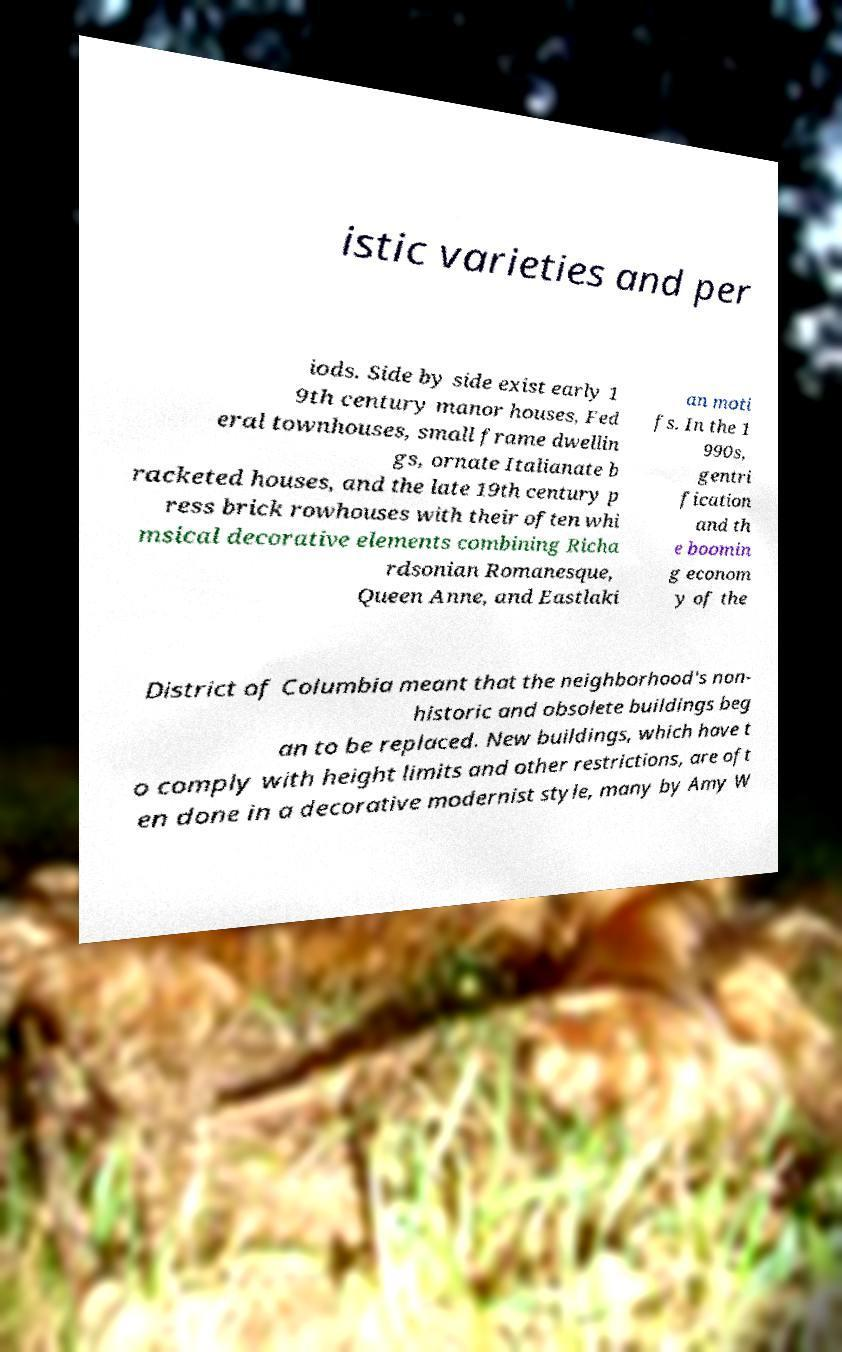Can you accurately transcribe the text from the provided image for me? istic varieties and per iods. Side by side exist early 1 9th century manor houses, Fed eral townhouses, small frame dwellin gs, ornate Italianate b racketed houses, and the late 19th century p ress brick rowhouses with their often whi msical decorative elements combining Richa rdsonian Romanesque, Queen Anne, and Eastlaki an moti fs. In the 1 990s, gentri fication and th e boomin g econom y of the District of Columbia meant that the neighborhood's non- historic and obsolete buildings beg an to be replaced. New buildings, which have t o comply with height limits and other restrictions, are oft en done in a decorative modernist style, many by Amy W 